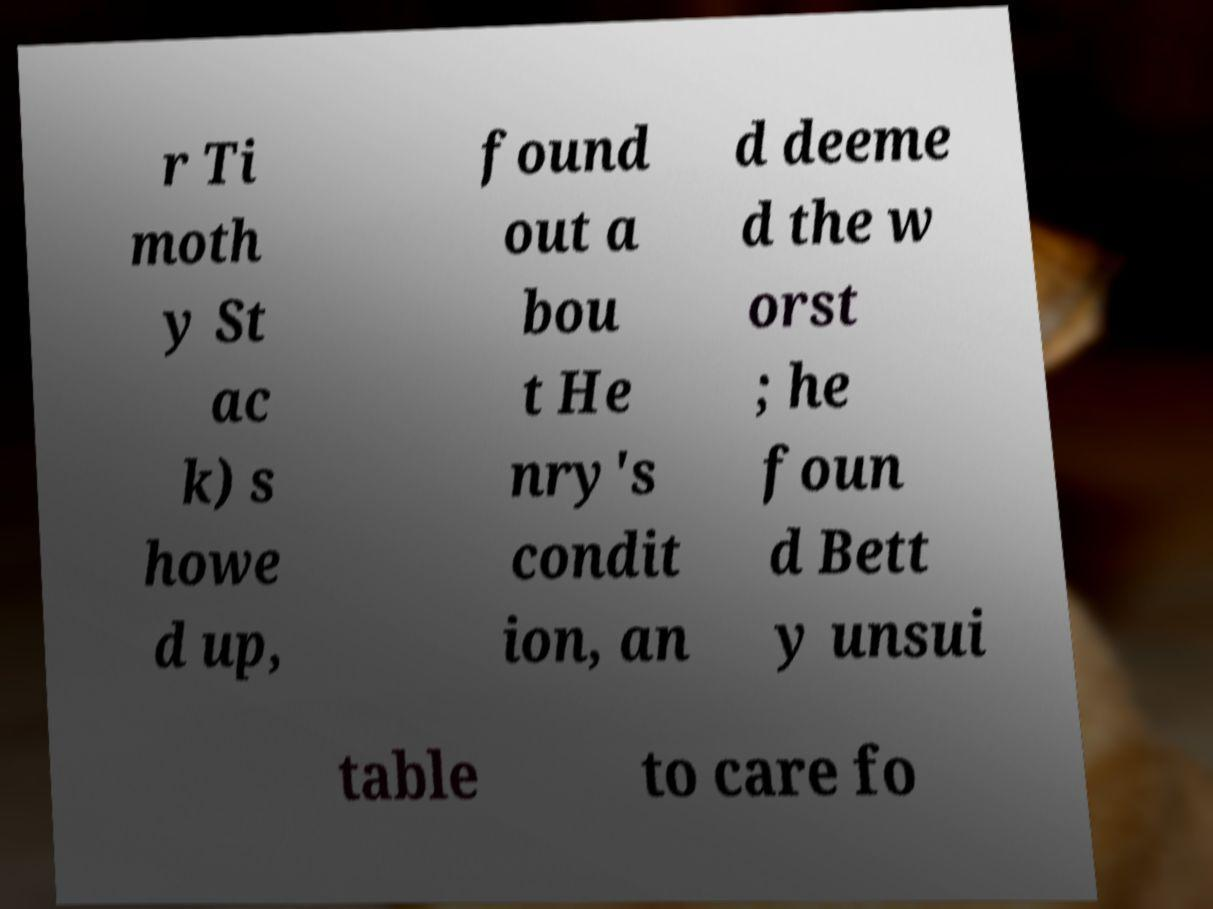Can you read and provide the text displayed in the image?This photo seems to have some interesting text. Can you extract and type it out for me? r Ti moth y St ac k) s howe d up, found out a bou t He nry's condit ion, an d deeme d the w orst ; he foun d Bett y unsui table to care fo 